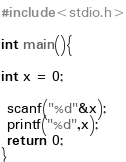<code> <loc_0><loc_0><loc_500><loc_500><_C_>#include<stdio.h>

int main(){

int x = 0;

 scanf("%d"&x);
 printf("%d",x);
 return 0;
}</code> 